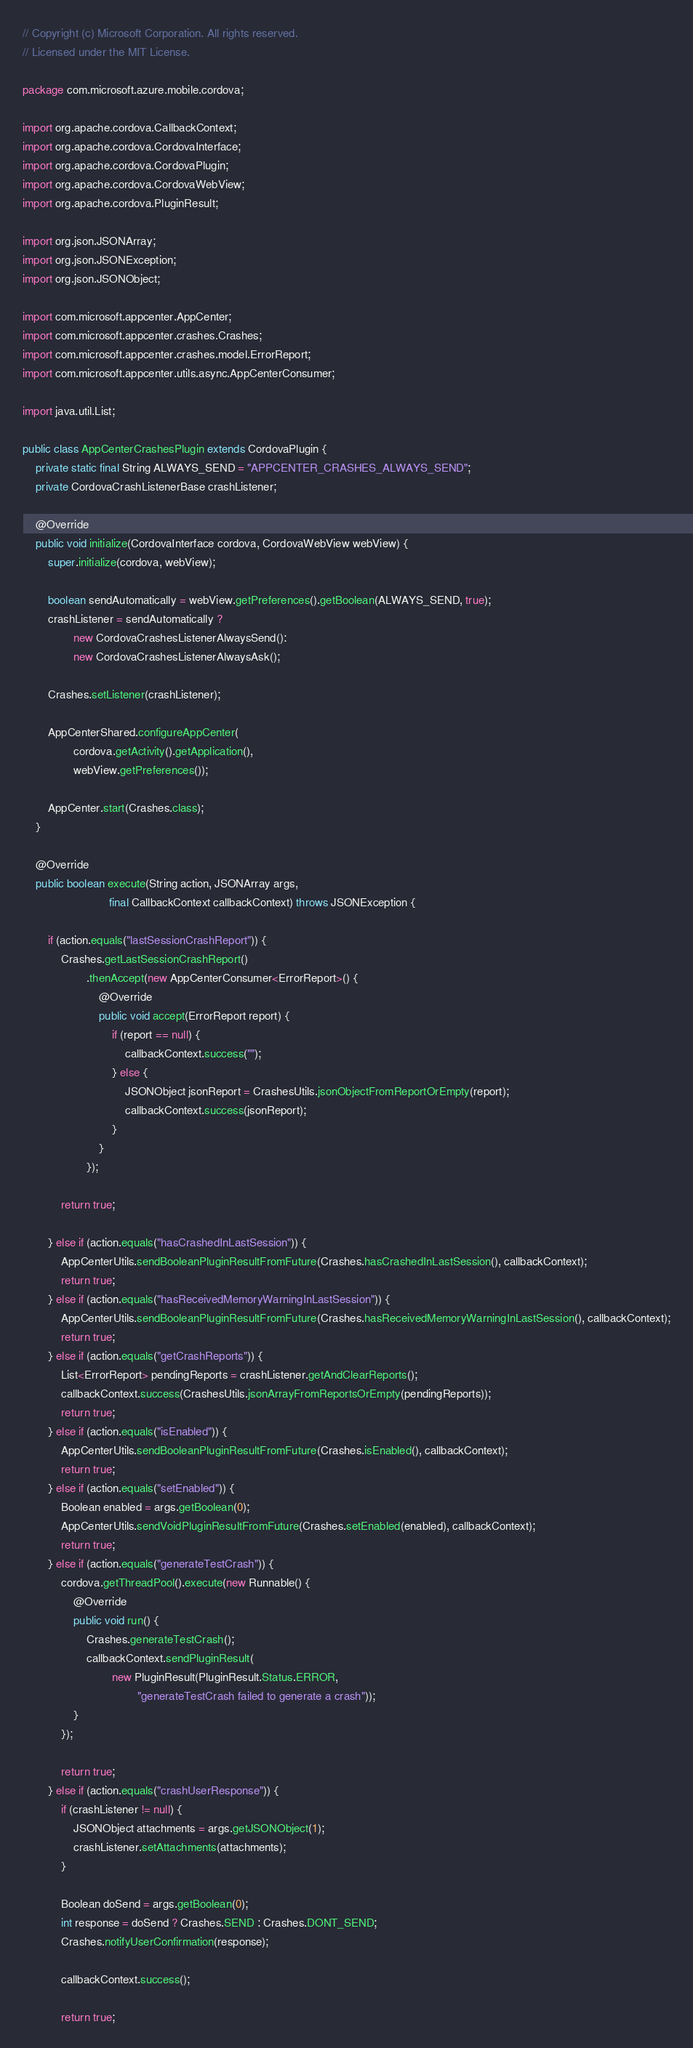Convert code to text. <code><loc_0><loc_0><loc_500><loc_500><_Java_>// Copyright (c) Microsoft Corporation. All rights reserved.
// Licensed under the MIT License.

package com.microsoft.azure.mobile.cordova;

import org.apache.cordova.CallbackContext;
import org.apache.cordova.CordovaInterface;
import org.apache.cordova.CordovaPlugin;
import org.apache.cordova.CordovaWebView;
import org.apache.cordova.PluginResult;

import org.json.JSONArray;
import org.json.JSONException;
import org.json.JSONObject;

import com.microsoft.appcenter.AppCenter;
import com.microsoft.appcenter.crashes.Crashes;
import com.microsoft.appcenter.crashes.model.ErrorReport;
import com.microsoft.appcenter.utils.async.AppCenterConsumer;

import java.util.List;

public class AppCenterCrashesPlugin extends CordovaPlugin {
    private static final String ALWAYS_SEND = "APPCENTER_CRASHES_ALWAYS_SEND";
    private CordovaCrashListenerBase crashListener;

    @Override
    public void initialize(CordovaInterface cordova, CordovaWebView webView) {
        super.initialize(cordova, webView);

        boolean sendAutomatically = webView.getPreferences().getBoolean(ALWAYS_SEND, true);
        crashListener = sendAutomatically ?
                new CordovaCrashesListenerAlwaysSend():
                new CordovaCrashesListenerAlwaysAsk();

        Crashes.setListener(crashListener);

        AppCenterShared.configureAppCenter(
                cordova.getActivity().getApplication(),
                webView.getPreferences());

        AppCenter.start(Crashes.class);
    }

    @Override
    public boolean execute(String action, JSONArray args,
                           final CallbackContext callbackContext) throws JSONException {

        if (action.equals("lastSessionCrashReport")) {
            Crashes.getLastSessionCrashReport()
                    .thenAccept(new AppCenterConsumer<ErrorReport>() {
                        @Override
                        public void accept(ErrorReport report) {
                            if (report == null) {
                                callbackContext.success("");
                            } else {
                                JSONObject jsonReport = CrashesUtils.jsonObjectFromReportOrEmpty(report);
                                callbackContext.success(jsonReport);
                            }
                        }
                    });

            return true;

        } else if (action.equals("hasCrashedInLastSession")) {
            AppCenterUtils.sendBooleanPluginResultFromFuture(Crashes.hasCrashedInLastSession(), callbackContext);
            return true;
        } else if (action.equals("hasReceivedMemoryWarningInLastSession")) {
            AppCenterUtils.sendBooleanPluginResultFromFuture(Crashes.hasReceivedMemoryWarningInLastSession(), callbackContext);
            return true;
        } else if (action.equals("getCrashReports")) {
            List<ErrorReport> pendingReports = crashListener.getAndClearReports();
            callbackContext.success(CrashesUtils.jsonArrayFromReportsOrEmpty(pendingReports));
            return true;
        } else if (action.equals("isEnabled")) {
            AppCenterUtils.sendBooleanPluginResultFromFuture(Crashes.isEnabled(), callbackContext);
            return true;
        } else if (action.equals("setEnabled")) {
            Boolean enabled = args.getBoolean(0);
            AppCenterUtils.sendVoidPluginResultFromFuture(Crashes.setEnabled(enabled), callbackContext);
            return true;
        } else if (action.equals("generateTestCrash")) {
            cordova.getThreadPool().execute(new Runnable() {
                @Override
                public void run() {
                    Crashes.generateTestCrash();
                    callbackContext.sendPluginResult(
                            new PluginResult(PluginResult.Status.ERROR,
                                    "generateTestCrash failed to generate a crash"));
                }
            });

            return true;
        } else if (action.equals("crashUserResponse")) {
            if (crashListener != null) {
                JSONObject attachments = args.getJSONObject(1);
                crashListener.setAttachments(attachments);
            }

            Boolean doSend = args.getBoolean(0);
            int response = doSend ? Crashes.SEND : Crashes.DONT_SEND;
            Crashes.notifyUserConfirmation(response);

            callbackContext.success();

            return true;</code> 